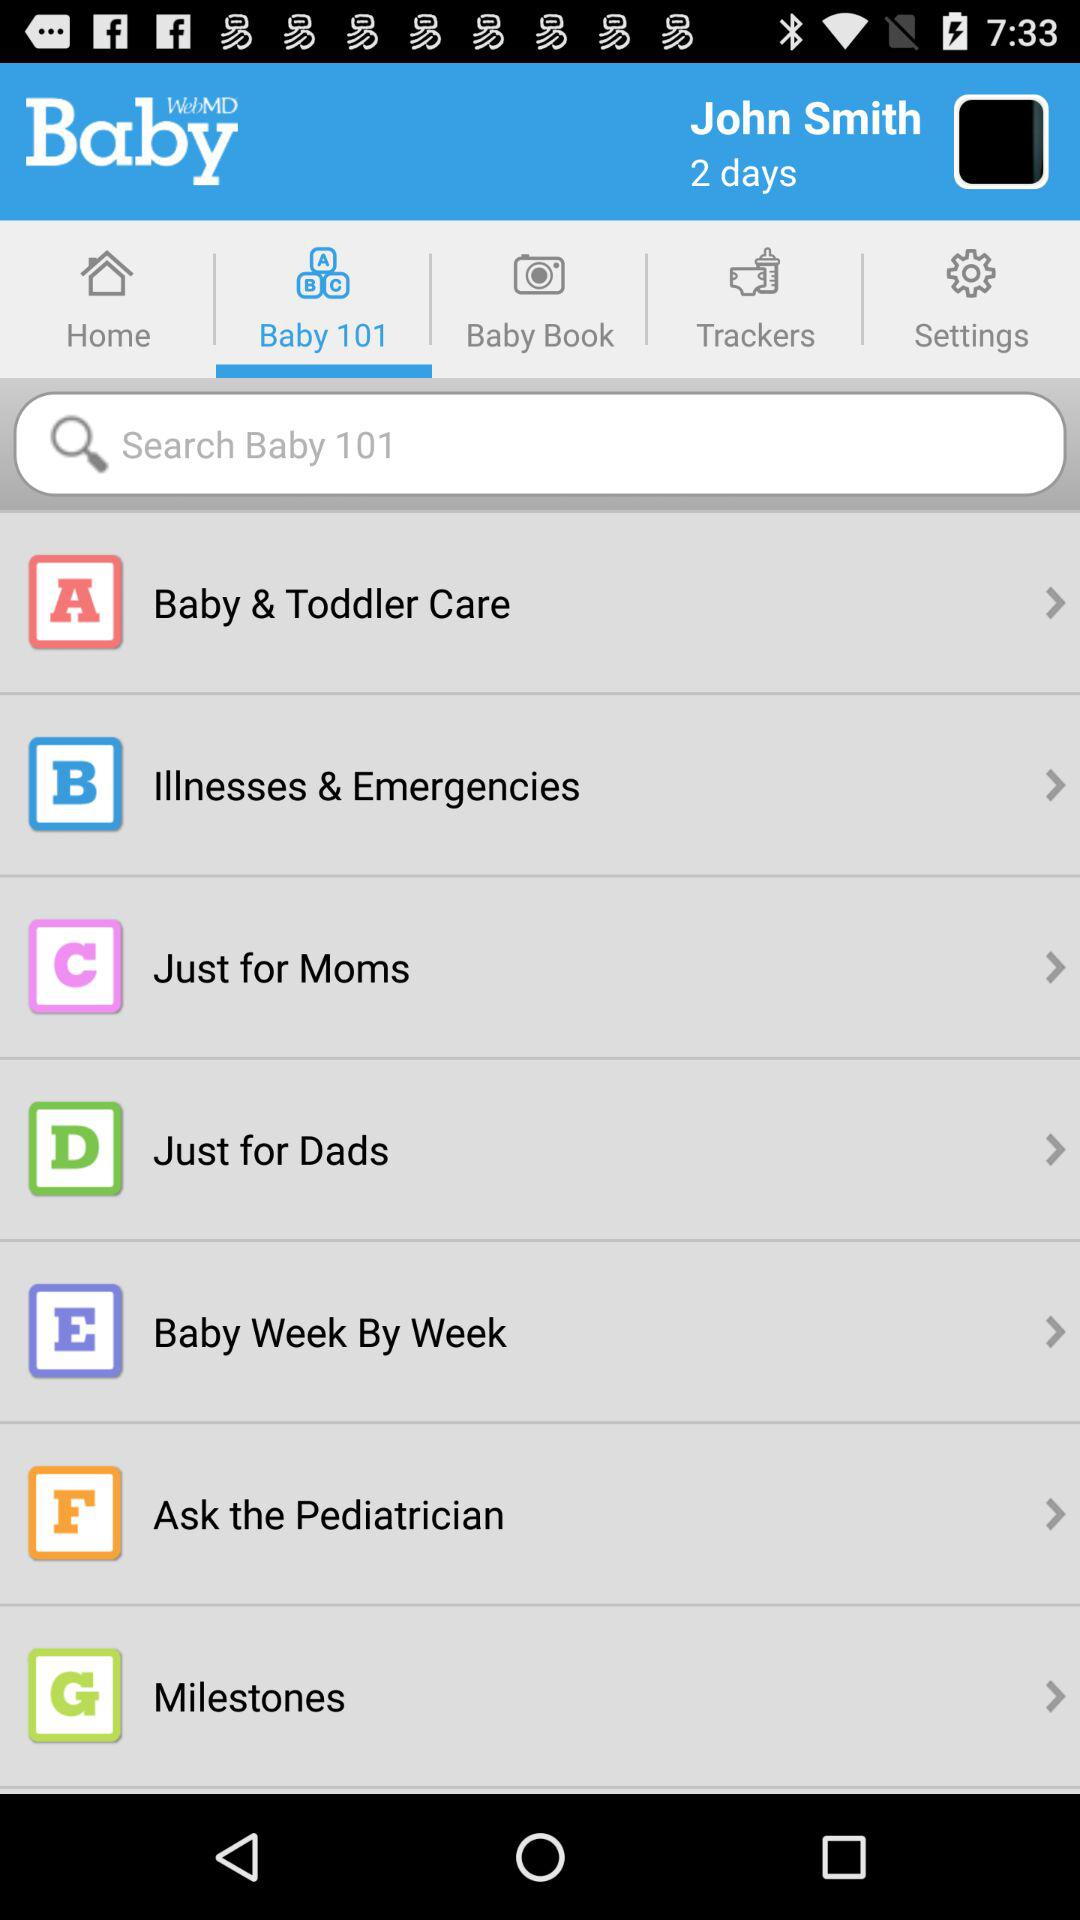What is the given time period? The given time period is "2 days". 